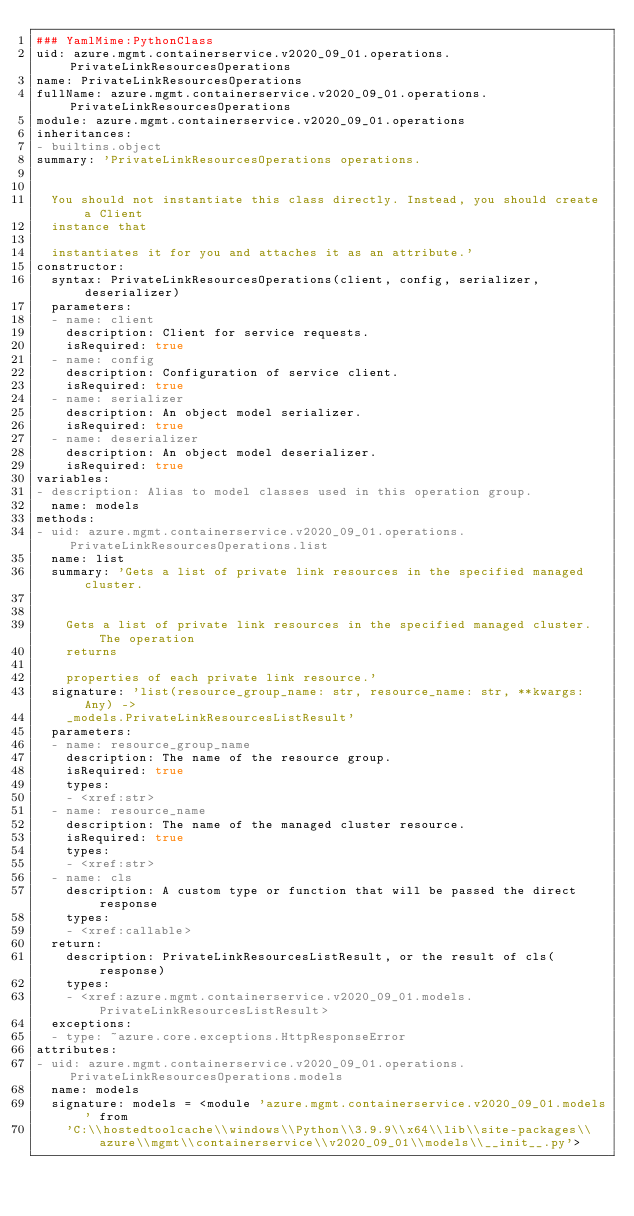Convert code to text. <code><loc_0><loc_0><loc_500><loc_500><_YAML_>### YamlMime:PythonClass
uid: azure.mgmt.containerservice.v2020_09_01.operations.PrivateLinkResourcesOperations
name: PrivateLinkResourcesOperations
fullName: azure.mgmt.containerservice.v2020_09_01.operations.PrivateLinkResourcesOperations
module: azure.mgmt.containerservice.v2020_09_01.operations
inheritances:
- builtins.object
summary: 'PrivateLinkResourcesOperations operations.


  You should not instantiate this class directly. Instead, you should create a Client
  instance that

  instantiates it for you and attaches it as an attribute.'
constructor:
  syntax: PrivateLinkResourcesOperations(client, config, serializer, deserializer)
  parameters:
  - name: client
    description: Client for service requests.
    isRequired: true
  - name: config
    description: Configuration of service client.
    isRequired: true
  - name: serializer
    description: An object model serializer.
    isRequired: true
  - name: deserializer
    description: An object model deserializer.
    isRequired: true
variables:
- description: Alias to model classes used in this operation group.
  name: models
methods:
- uid: azure.mgmt.containerservice.v2020_09_01.operations.PrivateLinkResourcesOperations.list
  name: list
  summary: 'Gets a list of private link resources in the specified managed cluster.


    Gets a list of private link resources in the specified managed cluster. The operation
    returns

    properties of each private link resource.'
  signature: 'list(resource_group_name: str, resource_name: str, **kwargs: Any) ->
    _models.PrivateLinkResourcesListResult'
  parameters:
  - name: resource_group_name
    description: The name of the resource group.
    isRequired: true
    types:
    - <xref:str>
  - name: resource_name
    description: The name of the managed cluster resource.
    isRequired: true
    types:
    - <xref:str>
  - name: cls
    description: A custom type or function that will be passed the direct response
    types:
    - <xref:callable>
  return:
    description: PrivateLinkResourcesListResult, or the result of cls(response)
    types:
    - <xref:azure.mgmt.containerservice.v2020_09_01.models.PrivateLinkResourcesListResult>
  exceptions:
  - type: ~azure.core.exceptions.HttpResponseError
attributes:
- uid: azure.mgmt.containerservice.v2020_09_01.operations.PrivateLinkResourcesOperations.models
  name: models
  signature: models = <module 'azure.mgmt.containerservice.v2020_09_01.models' from
    'C:\\hostedtoolcache\\windows\\Python\\3.9.9\\x64\\lib\\site-packages\\azure\\mgmt\\containerservice\\v2020_09_01\\models\\__init__.py'>
</code> 